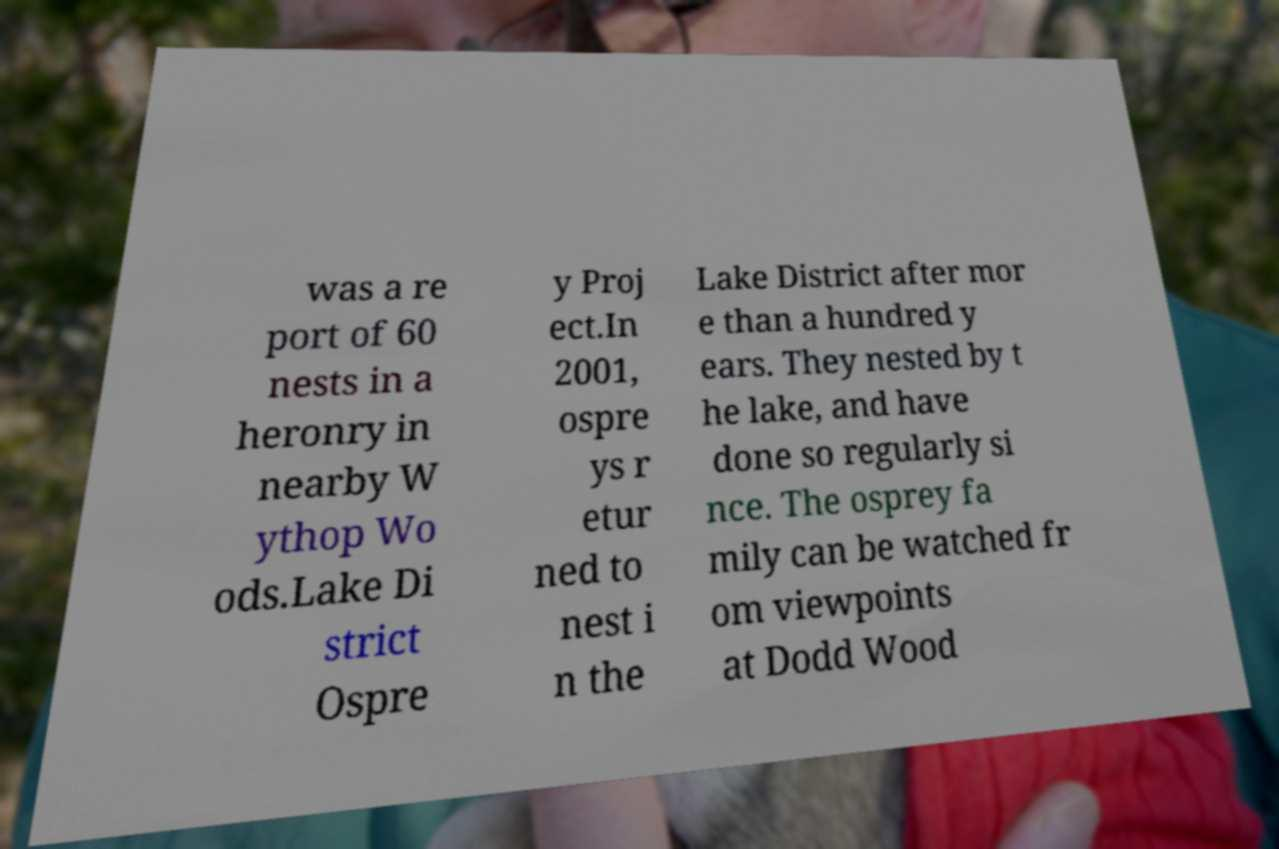Please read and relay the text visible in this image. What does it say? was a re port of 60 nests in a heronry in nearby W ythop Wo ods.Lake Di strict Ospre y Proj ect.In 2001, ospre ys r etur ned to nest i n the Lake District after mor e than a hundred y ears. They nested by t he lake, and have done so regularly si nce. The osprey fa mily can be watched fr om viewpoints at Dodd Wood 